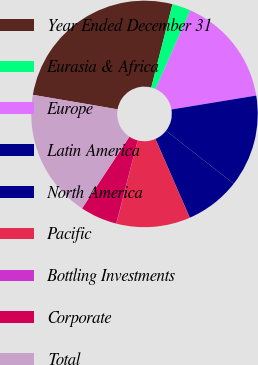Convert chart. <chart><loc_0><loc_0><loc_500><loc_500><pie_chart><fcel>Year Ended December 31<fcel>Eurasia & Africa<fcel>Europe<fcel>Latin America<fcel>North America<fcel>Pacific<fcel>Bottling Investments<fcel>Corporate<fcel>Total<nl><fcel>26.28%<fcel>2.65%<fcel>15.78%<fcel>13.15%<fcel>7.9%<fcel>10.53%<fcel>0.03%<fcel>5.28%<fcel>18.4%<nl></chart> 